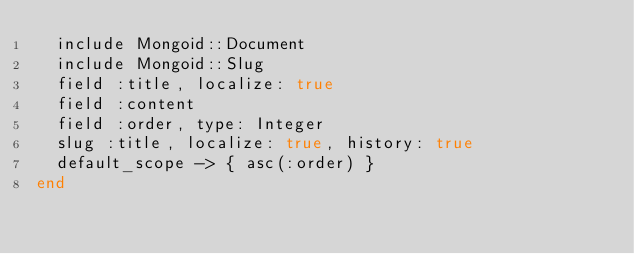<code> <loc_0><loc_0><loc_500><loc_500><_Ruby_>  include Mongoid::Document
  include Mongoid::Slug
  field :title, localize: true
  field :content
  field :order, type: Integer
  slug :title, localize: true, history: true
  default_scope -> { asc(:order) }
end
</code> 